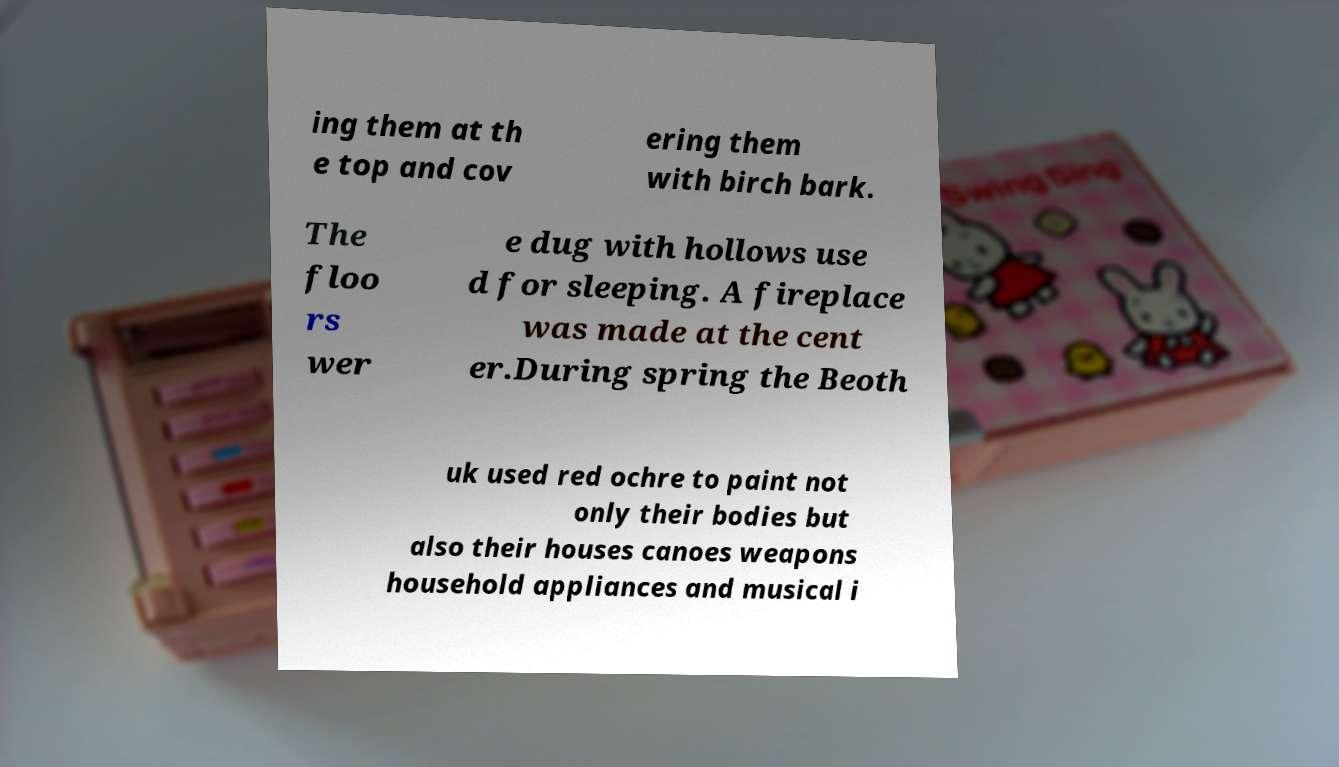Please read and relay the text visible in this image. What does it say? ing them at th e top and cov ering them with birch bark. The floo rs wer e dug with hollows use d for sleeping. A fireplace was made at the cent er.During spring the Beoth uk used red ochre to paint not only their bodies but also their houses canoes weapons household appliances and musical i 